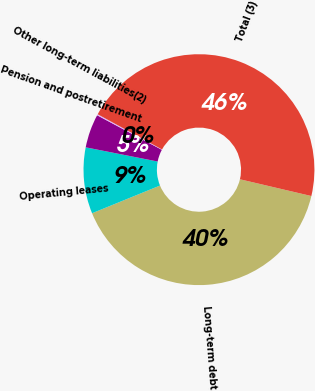<chart> <loc_0><loc_0><loc_500><loc_500><pie_chart><fcel>Long-term debt<fcel>Operating leases<fcel>Pension and postretirement<fcel>Other long-term liabilities(2)<fcel>Total (3)<nl><fcel>40.17%<fcel>9.26%<fcel>4.71%<fcel>0.16%<fcel>45.7%<nl></chart> 